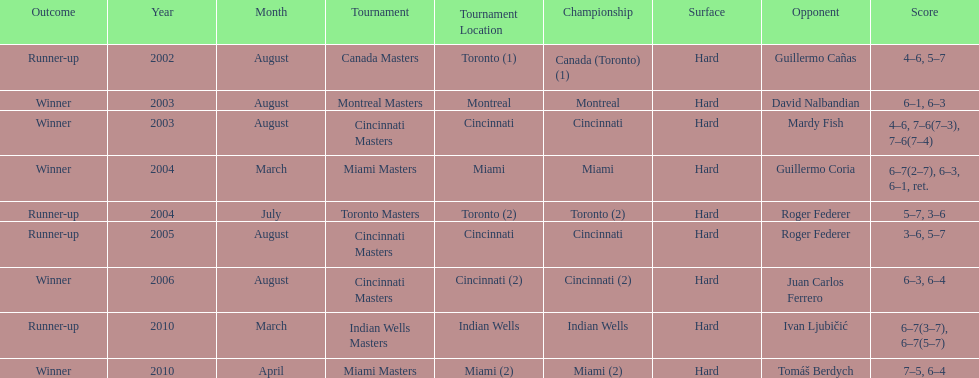How many times was roger federer a runner-up? 2. 